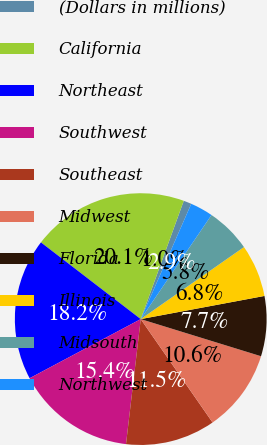Convert chart to OTSL. <chart><loc_0><loc_0><loc_500><loc_500><pie_chart><fcel>(Dollars in millions)<fcel>California<fcel>Northeast<fcel>Southwest<fcel>Southeast<fcel>Midwest<fcel>Florida<fcel>Illinois<fcel>Midsouth<fcel>Northwest<nl><fcel>1.02%<fcel>20.12%<fcel>18.21%<fcel>15.35%<fcel>11.53%<fcel>10.57%<fcel>7.71%<fcel>6.75%<fcel>5.8%<fcel>2.93%<nl></chart> 